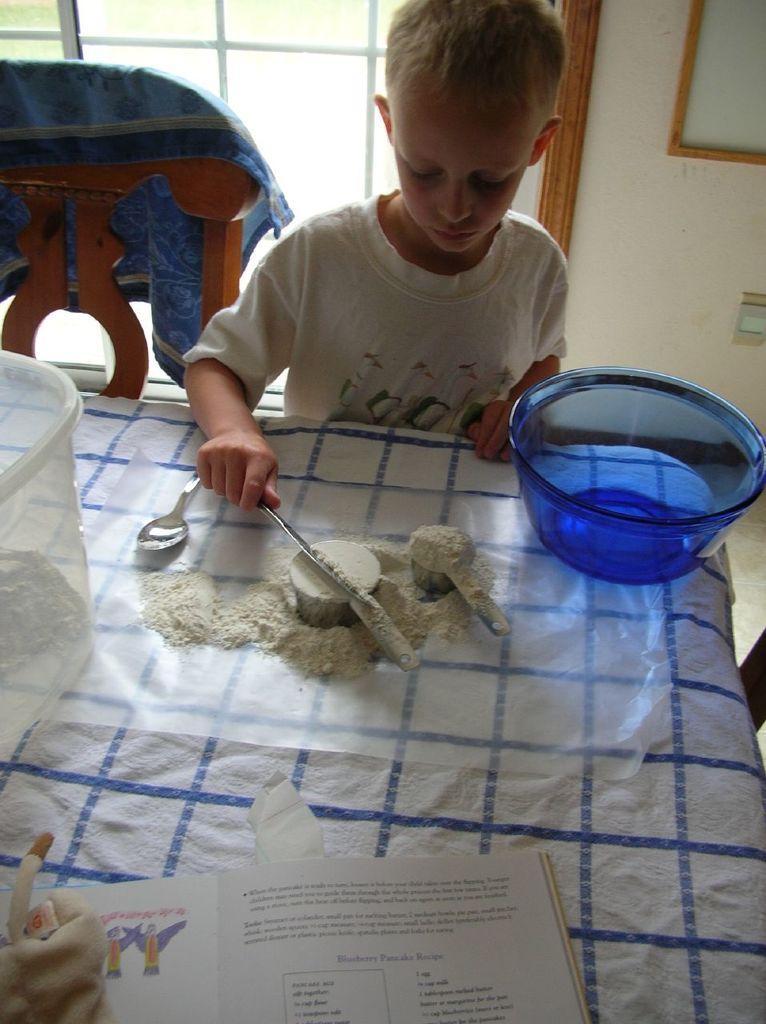Can you describe this image briefly? In this picture we can see a table with bowls, spoon, book, toys, powder and some objects on it, chair with a cloth on it, boy standing and in the background we can see a frame on the wall, rods. 